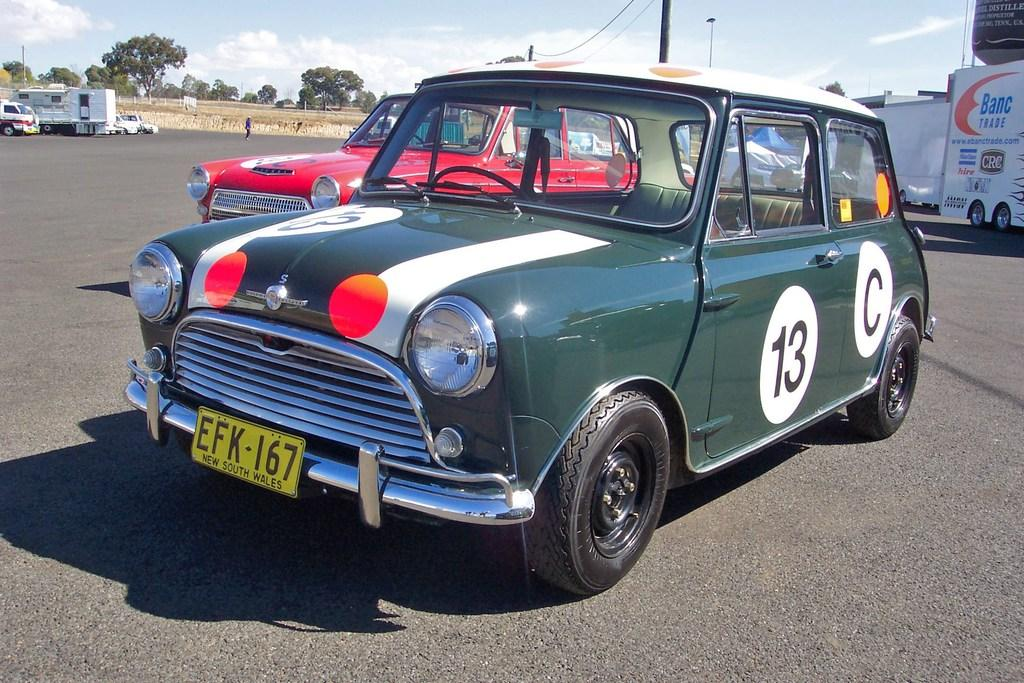What can be seen on the road in the image? There are vehicles on the road in the image. Are there any people visible in the image? Yes, there is a person standing on the road in the background. What can be seen in the distance behind the vehicles and person? There are many trees visible in the background. What type of apparatus is being used by the person on the wrist in the image? There is no apparatus or wrist visible in the image; the person is simply standing on the road. 